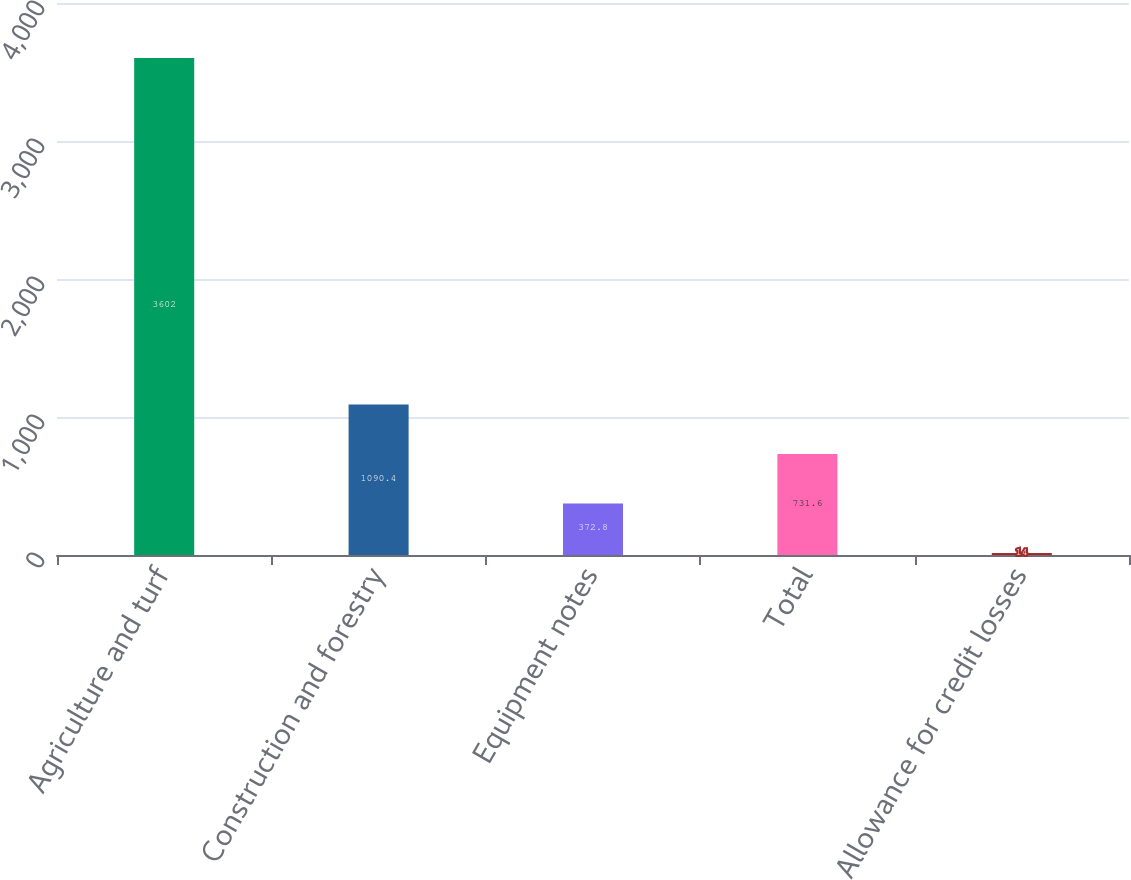<chart> <loc_0><loc_0><loc_500><loc_500><bar_chart><fcel>Agriculture and turf<fcel>Construction and forestry<fcel>Equipment notes<fcel>Total<fcel>Allowance for credit losses<nl><fcel>3602<fcel>1090.4<fcel>372.8<fcel>731.6<fcel>14<nl></chart> 